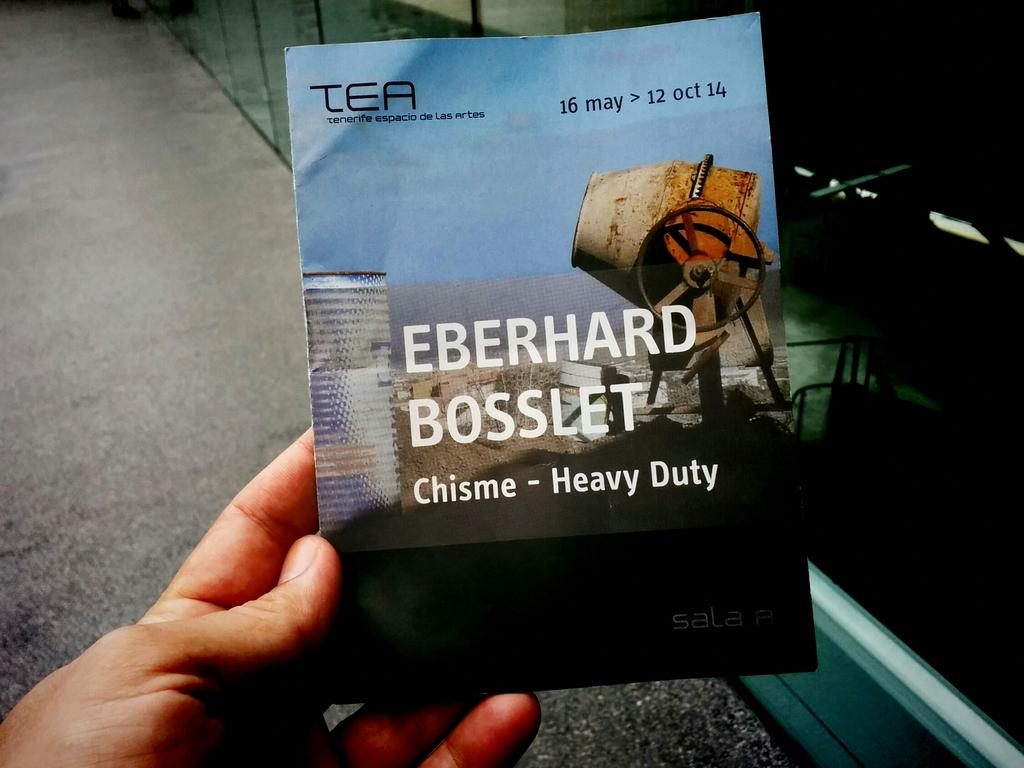<image>
Present a compact description of the photo's key features. a book called chisme heavy duty and a man is holding it 